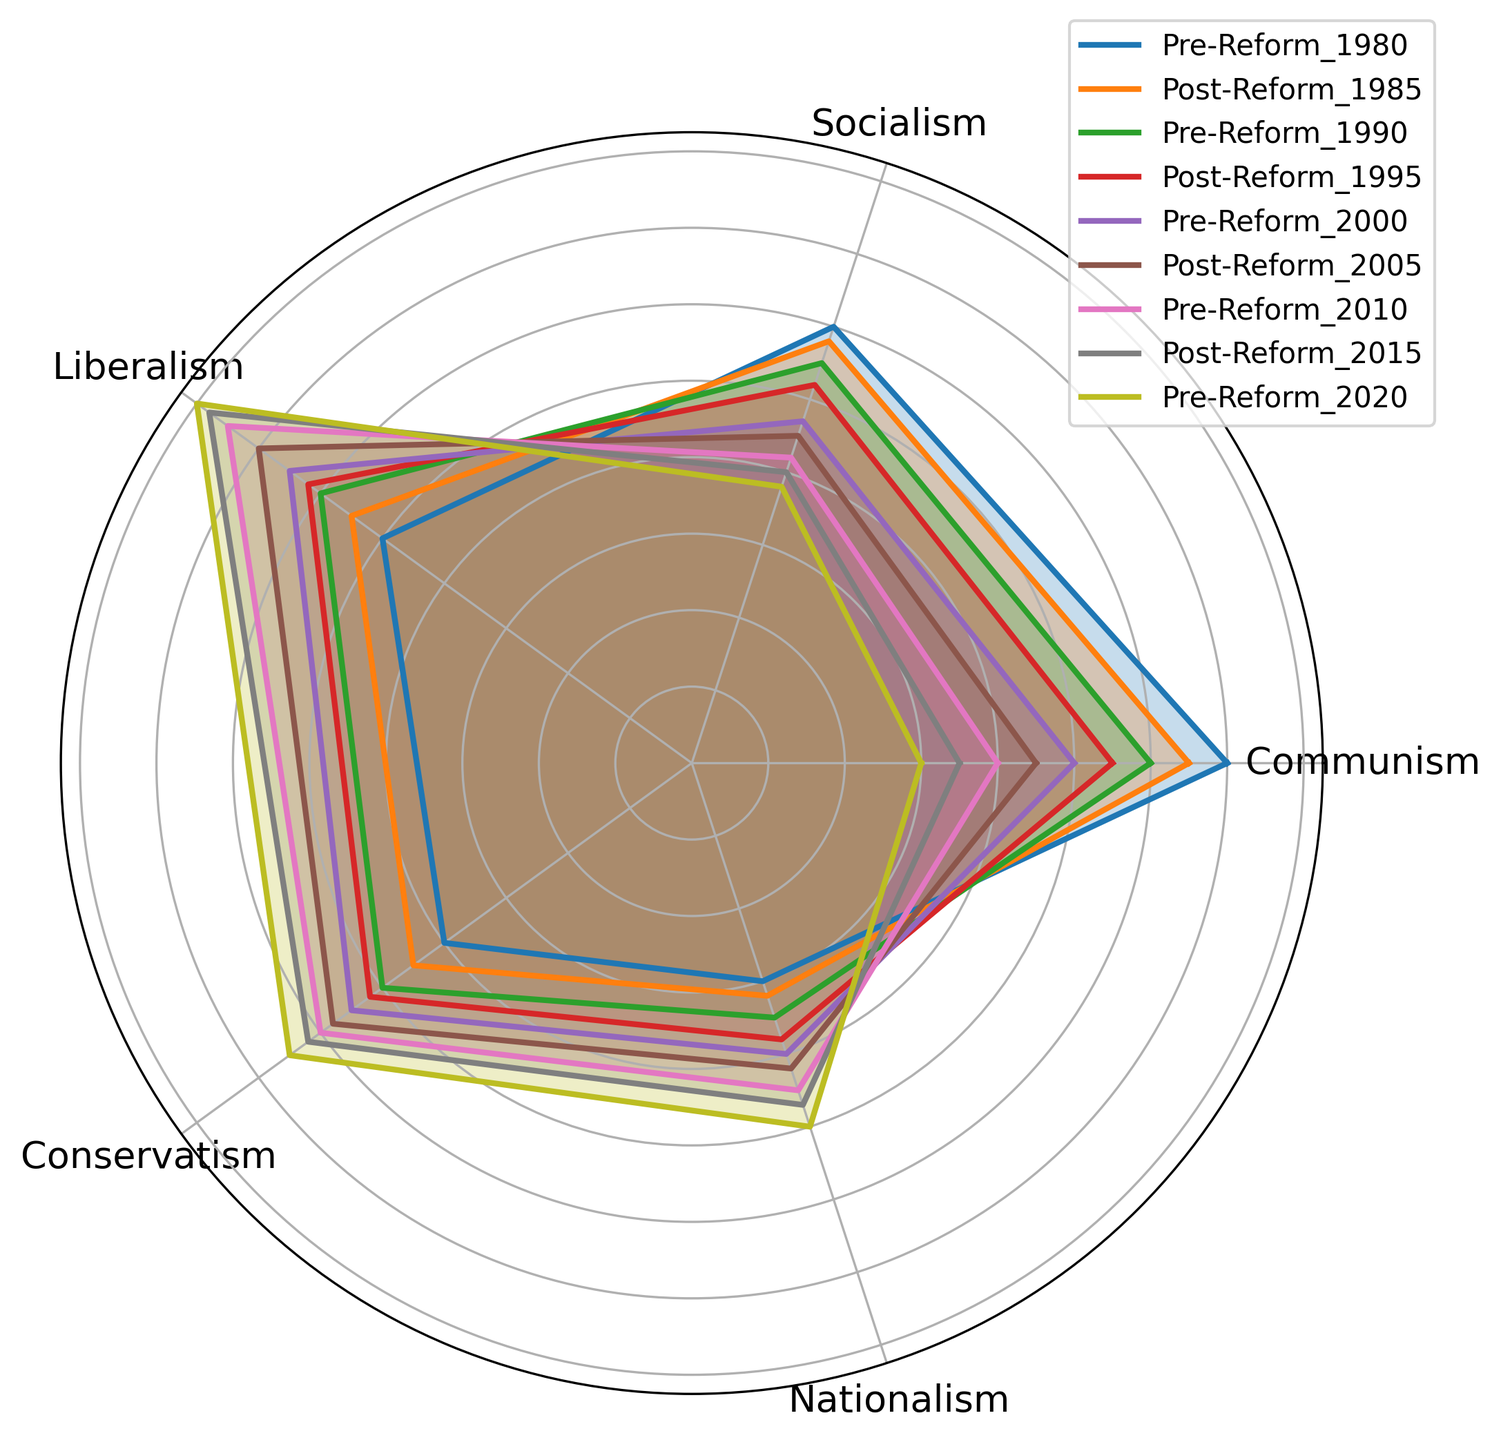What trend can be observed in the public opinion on Communism from 1980 to 2020? By observing the values over the years for Communism: starting from 70 in 1980, the values generally decline through each reform period, ending at 30 in 2020. This indicates a downward trend in public opinion on Communism.
Answer: Decline Which political ideology experienced the highest increase in public opinion from 1980 to 2020? By comparing the increase in value for each ideology from 1980 to 2020: Communism decreased from 70 to 30, Socialism from 60 to 38, Liberalism increased from 50 to 80, Conservatism increased from 40 to 65, and Nationalism increased from 30 to 50. Therefore, Liberalism experienced the highest increase.
Answer: Liberalism During the Post-Reform years, which political ideology showed a consistent increase in public opinion across all periods? By evaluating the Post-Reform values for each ideology: Liberalism showed values of 55 (1985), 62 (1995), 70 (2005), 78 (2015), and 80 (2020); hence it consistently increased.
Answer: Liberalism What is the difference in public opinion on Conservatism between Pre-Reform 1980 and Post-Reform 2015? The value for Conservatism in Pre-Reform 1980 is 40 and in Post-Reform 2015 is 62. The difference is 62 - 40.
Answer: 22 Looking at the radar chart, which Reform period had the most balanced public opinion across all political ideologies (i.e., values closest to each other)? The most balanced opinion would be the period where the values are most similar; for instance, Pre-Reform 1990 has values 60, 55, 60, 50, 35 which are relatively closer to each other compared to other periods.
Answer: Pre-Reform 1990 What's the average public opinion on Socialism during the Pre-Reform periods? The Pre-Reform periods for Socialism are 60 (1980), 55 (1990), 47 (2000), 42 (2010), 38 (2020). Sum = 60 + 55 + 47 + 42 + 38 = 242, and there are 5 periods. Thus, the average is 242 / 5.
Answer: 48.4 Which ideology had the smallest change in public opinion between Pre-Reform 2000 and Post-Reform 2005? The values for Pre-Reform 2000 and Post-Reform 2005 for each ideology: Communism from 50 to 45, Socialism from 47 to 45, Liberalism from 65 to 70, Conservatism from 55 to 58, and Nationalism from 40 to 42. The smallest change is for Socialism with a difference of 2.
Answer: Socialism Which political ideology had the highest public opinion in the Post-Reform 2020 period? The Post-Reform 2020 values are Communism 30, Socialism 38, Liberalism 80, Conservatism 65, and Nationalism 50. Therefore, Liberalism has the highest value.
Answer: Liberalism From the radar chart, how does the change in public opinion on Nationalism between Pre-Reform 1980 and Pre-Reform 2020 compare with the change in opinion on Communism over the same period? Nationalism's values are 30 (1980) and 50 (2020), indicating an increase of 20. Communism's values are 70 (1980) and 30 (2020), indicating a decrease of 40. Therefore, Nationalism increased by 20, while Communism decreased by 40.
Answer: Nationalism increased by 20, Communism decreased by 40 